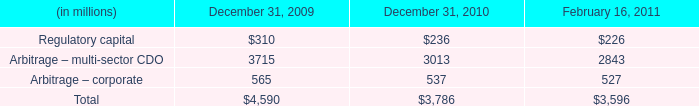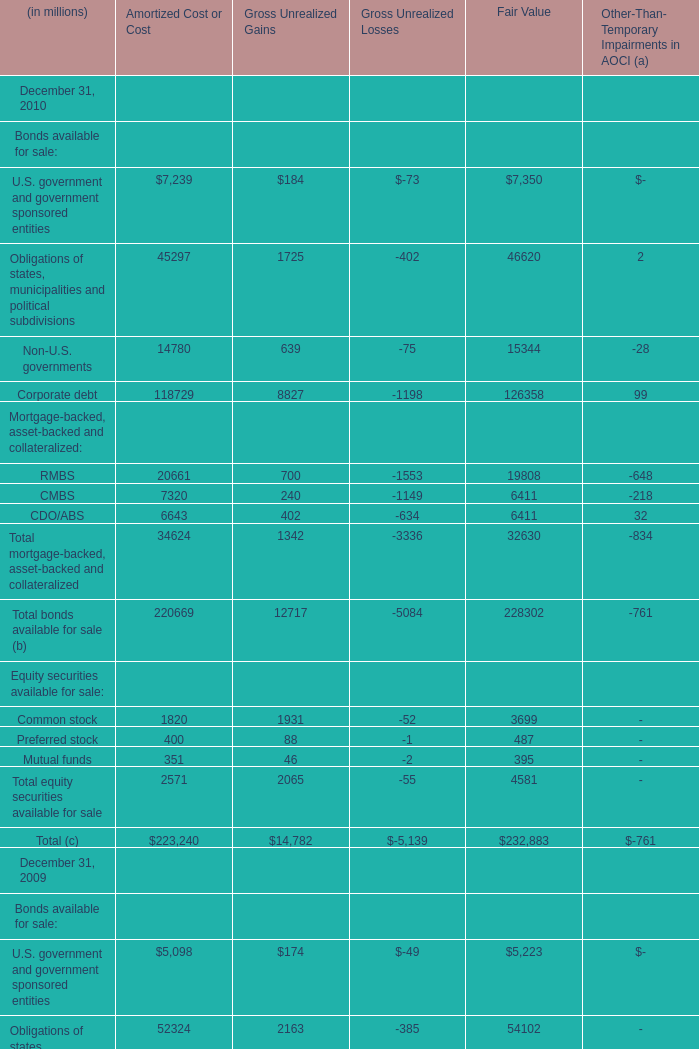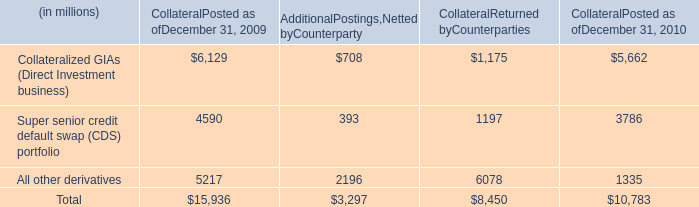What's the total amount of mortgage-backed, asset-backed and collateralized of Amortized Cost or Cost without those smaller than 7000, in 2010? (in million) 
Computations: (20661 + 7320)
Answer: 27981.0. 